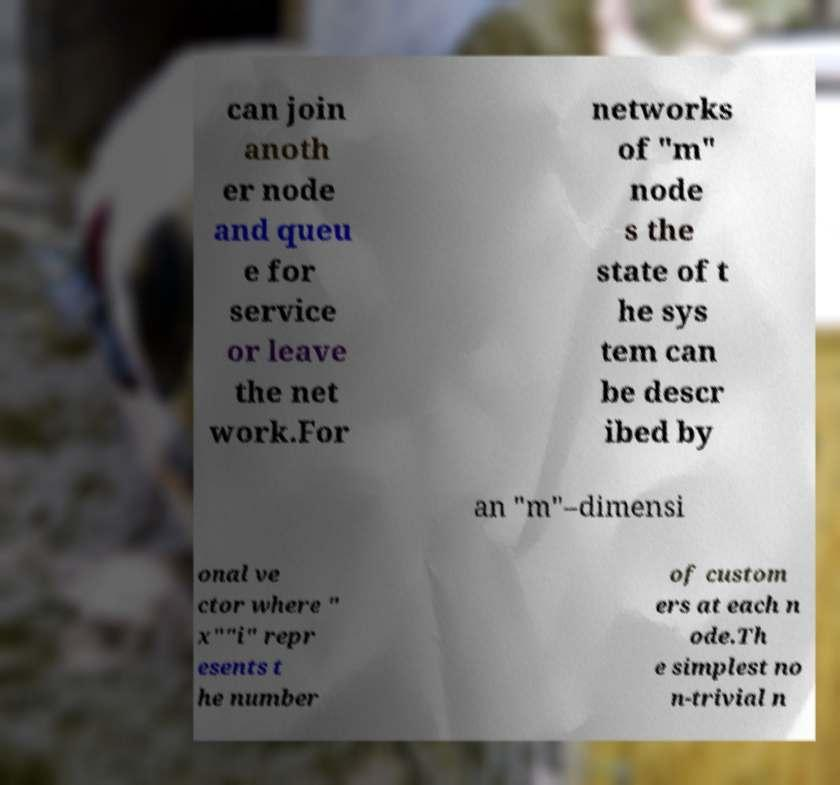For documentation purposes, I need the text within this image transcribed. Could you provide that? can join anoth er node and queu e for service or leave the net work.For networks of "m" node s the state of t he sys tem can be descr ibed by an "m"–dimensi onal ve ctor where " x""i" repr esents t he number of custom ers at each n ode.Th e simplest no n-trivial n 